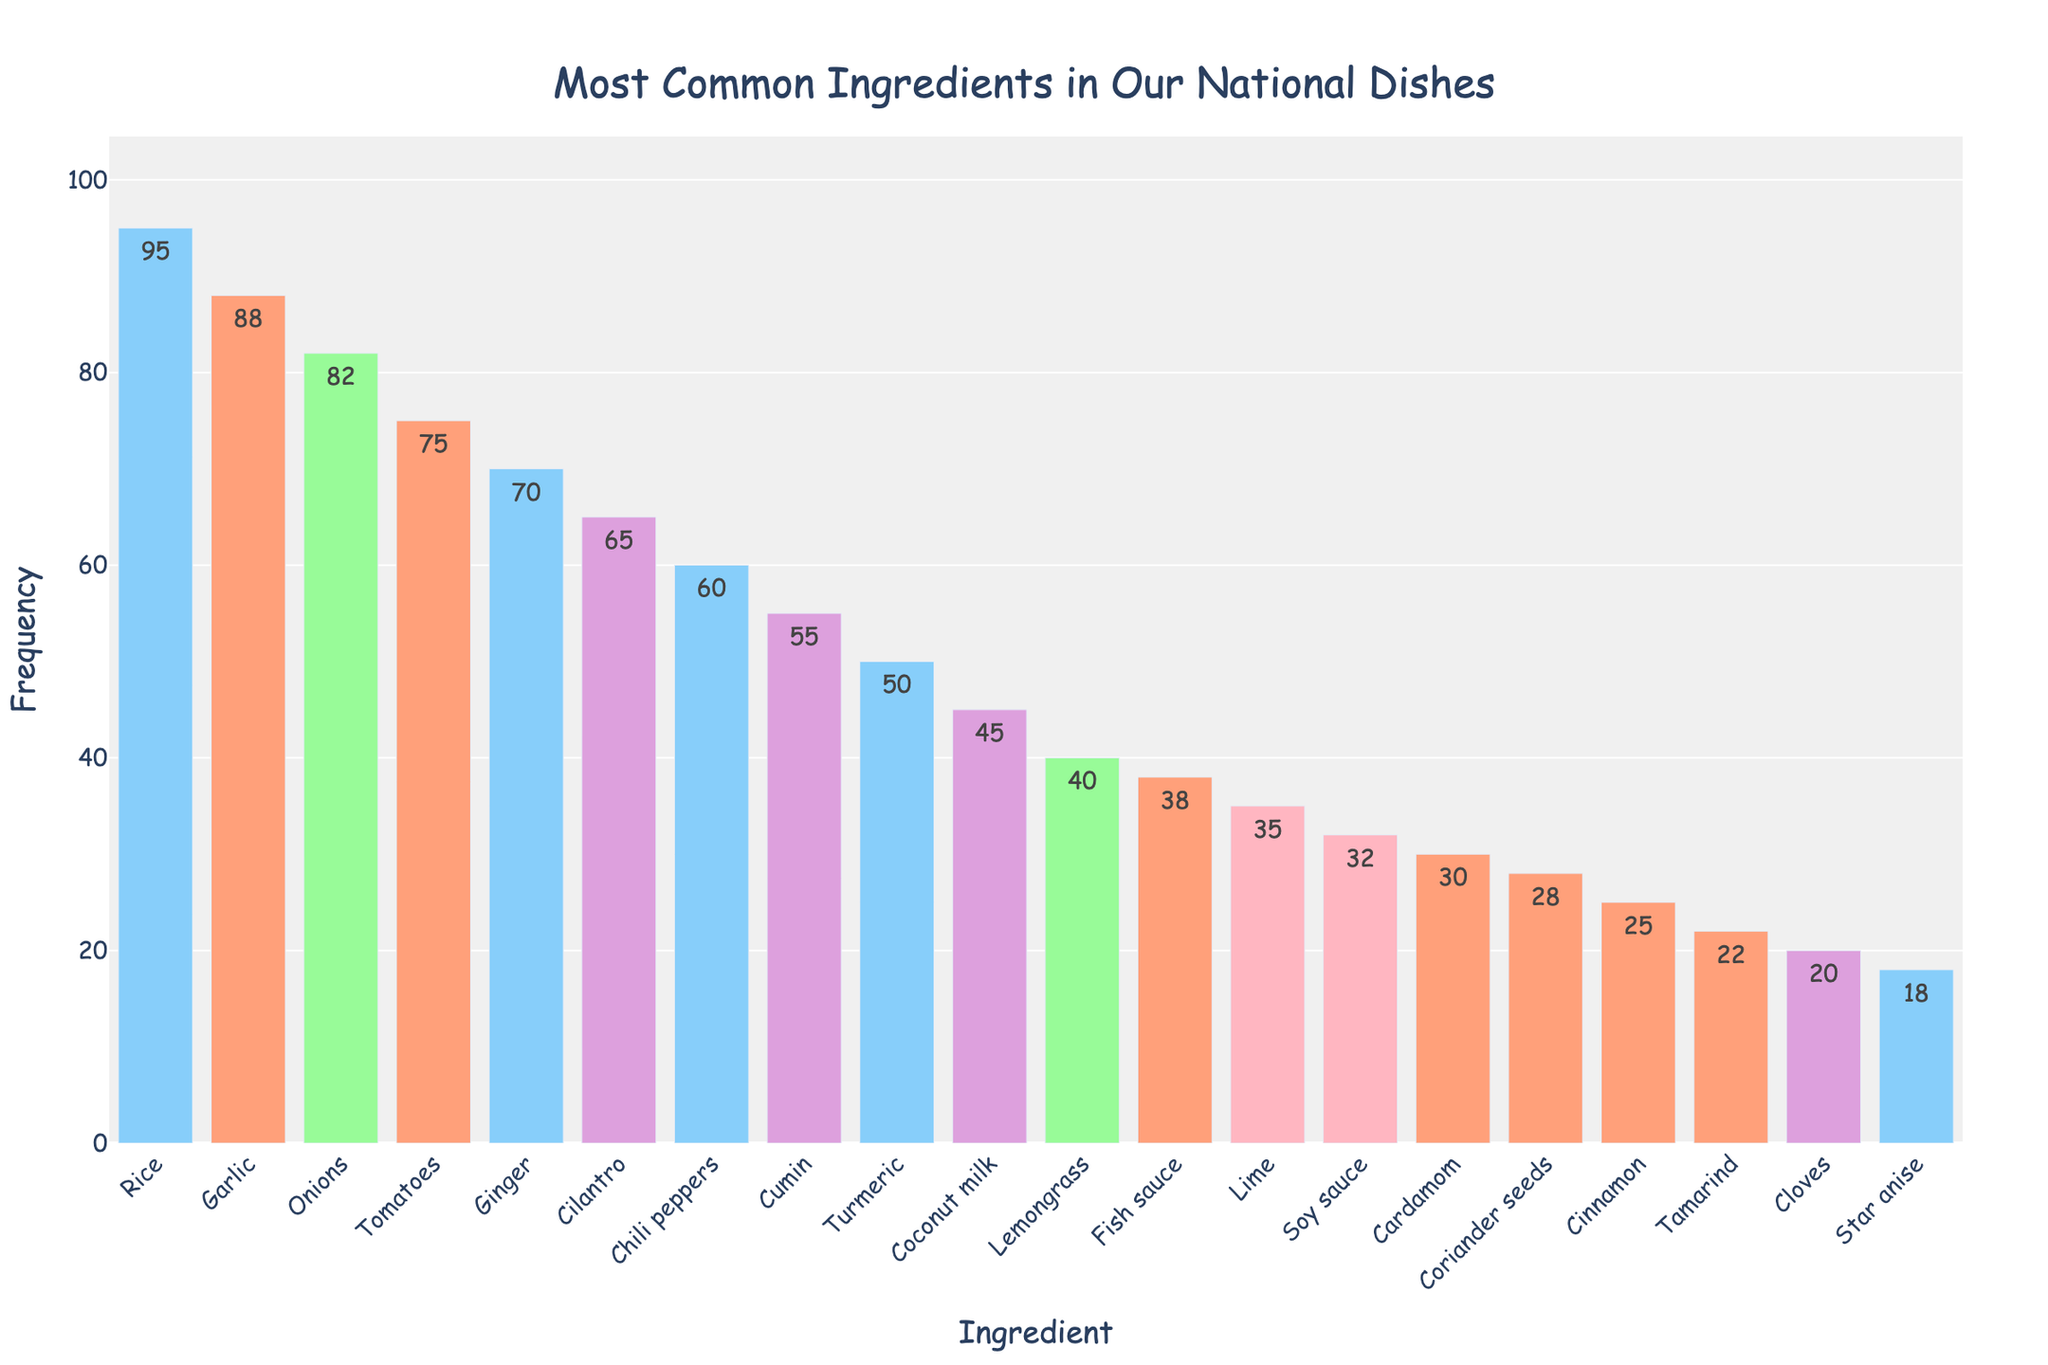What's the most common ingredient used in our national dishes? The most common ingredient is the one with the highest frequency. According to the chart, Rice has the highest frequency of 95.
Answer: Rice Which ingredient is used more frequently, Garlic or Ginger? Compare the frequencies of Garlic and Ginger. Garlic has a frequency of 88 while Ginger has 70.
Answer: Garlic What is the total frequency of the top three ingredients? The top three ingredients are Rice (95), Garlic (88), and Onions (82). Sum these frequencies: 95 + 88 + 82 = 265.
Answer: 265 Which ingredient has a lower frequency, Coconut milk or Soy sauce? Compare the frequencies of Coconut milk (45) and Soy sauce (32). Coconut milk has a higher frequency, so Soy sauce has the lower frequency.
Answer: Soy sauce How many ingredients have a frequency greater than 50? Count the ingredients with a frequency greater than 50. They are: Rice, Garlic, Onions, Tomatoes, Ginger, Cilantro, Chili peppers, and Cumin. That adds up to 8 ingredients.
Answer: 8 What is the difference in frequency between Chili peppers and Cumin? Subtract the frequency of Cumin (55) from the frequency of Chili peppers (60): 60 - 55 = 5.
Answer: 5 Which ingredient has the shortest bar on the chart? The shortest bar represents the ingredient with the lowest frequency. According to the chart, Star anise has the lowest frequency of 18.
Answer: Star anise Which colors are most frequently associated with the bar representing Lime? Look at the random color assignments of the bars. According to the description, the colors are within the set: pink, salmon, light green, light blue, and purple. Identify the colors predominantly associated with Lime visually.
Answer: light green, pink Are Onions or Turmeric used more frequently, and by how much? Compare the frequencies of Onions (82) and Turmeric (50). The difference is 82 - 50 = 32.
Answer: Onions by 32 What is the combined frequency of the ingredients that have a frequency of 30 or below? Sum the frequencies for ingredients: Cardamom (30), Coriander seeds (28), Cinnamon (25), Tamarind (22), Cloves (20), and Star anise (18). 30 + 28 + 25 + 22 + 20 + 18 = 143.
Answer: 143 